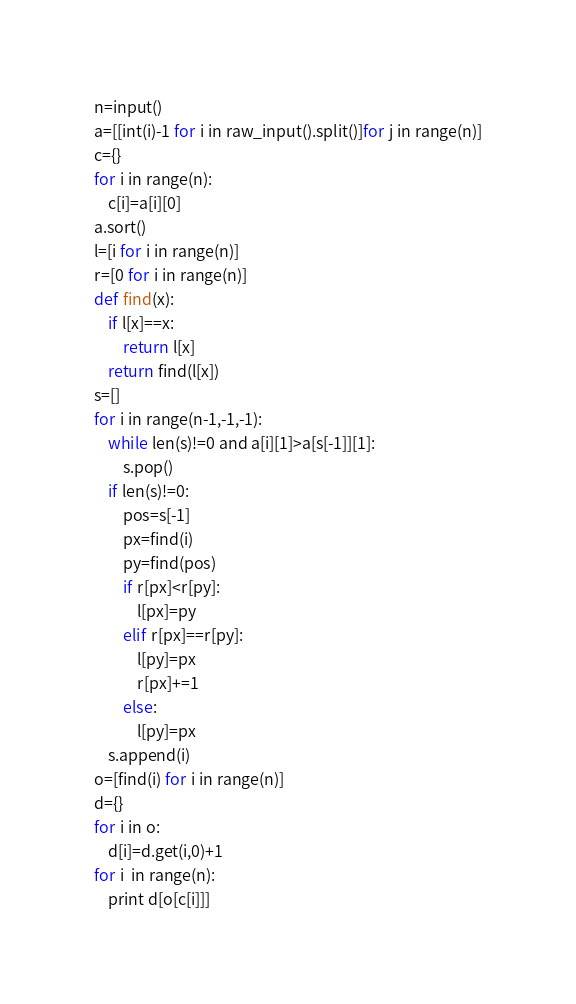Convert code to text. <code><loc_0><loc_0><loc_500><loc_500><_Python_>n=input()
a=[[int(i)-1 for i in raw_input().split()]for j in range(n)]
c={}
for i in range(n):
    c[i]=a[i][0]
a.sort()
l=[i for i in range(n)]
r=[0 for i in range(n)]
def find(x):
    if l[x]==x:
        return l[x]
    return find(l[x])
s=[]
for i in range(n-1,-1,-1):
    while len(s)!=0 and a[i][1]>a[s[-1]][1]:
        s.pop()
    if len(s)!=0:
        pos=s[-1]
        px=find(i)
        py=find(pos)
        if r[px]<r[py]:
            l[px]=py
        elif r[px]==r[py]:
            l[py]=px
            r[px]+=1
        else:
            l[py]=px
    s.append(i)
o=[find(i) for i in range(n)]
d={}
for i in o:
    d[i]=d.get(i,0)+1
for i  in range(n):
    print d[o[c[i]]]
</code> 